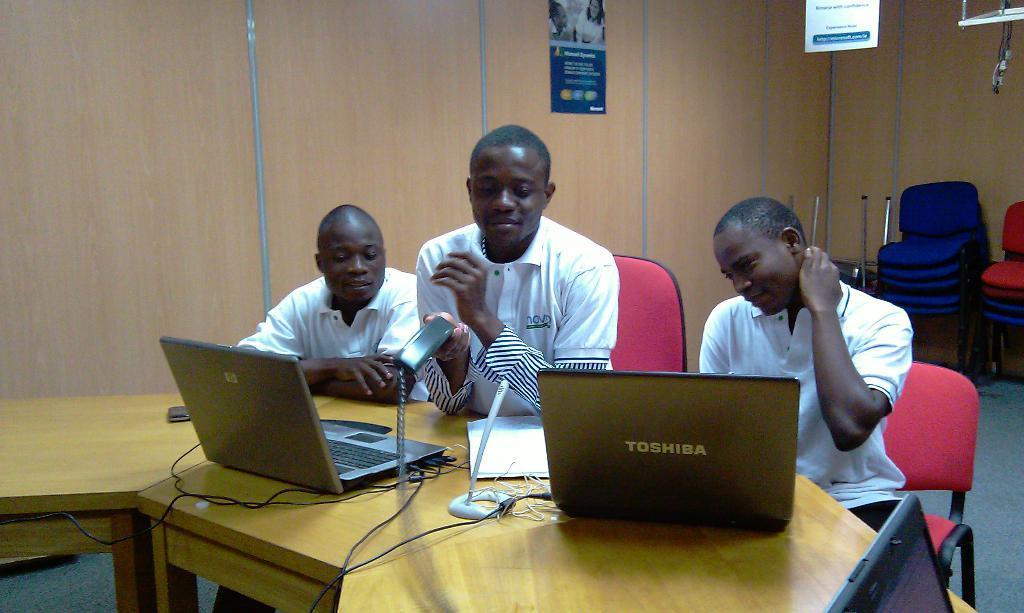Please provide a concise description of this image. In this picture we can see three persons are sitting on the chairs. This is table. On the table there are laptops. This is floor. On the background there is a wall. 